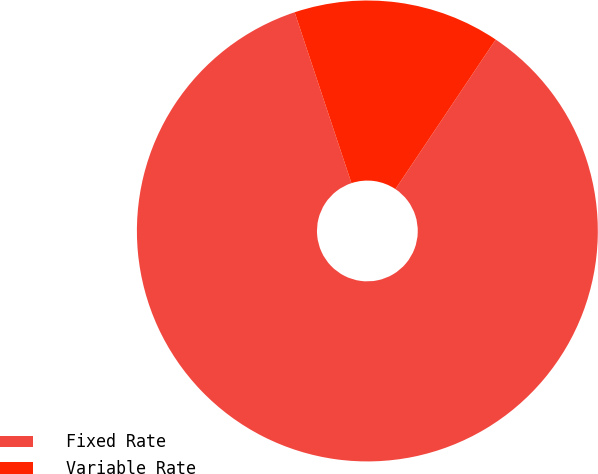<chart> <loc_0><loc_0><loc_500><loc_500><pie_chart><fcel>Fixed Rate<fcel>Variable Rate<nl><fcel>85.49%<fcel>14.51%<nl></chart> 